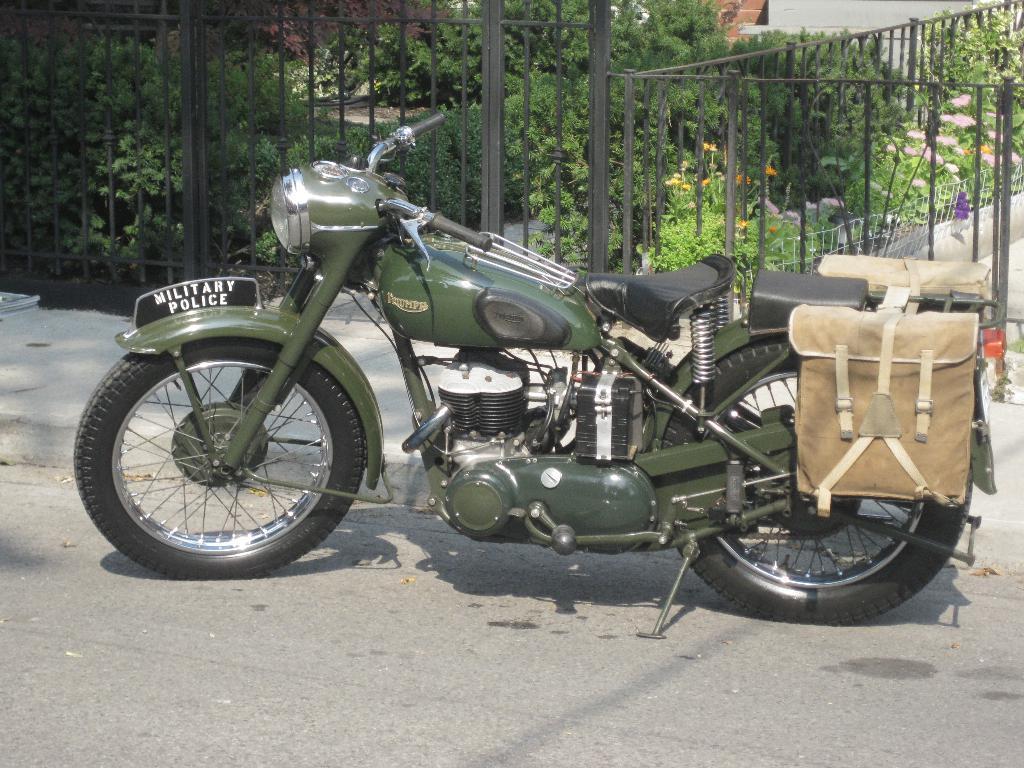In one or two sentences, can you explain what this image depicts? There is a bike. Which is having two bags attached to the back seat and parked aside the road. In the background, there is a black color fencing, there is a garden. In which, there are plants. 